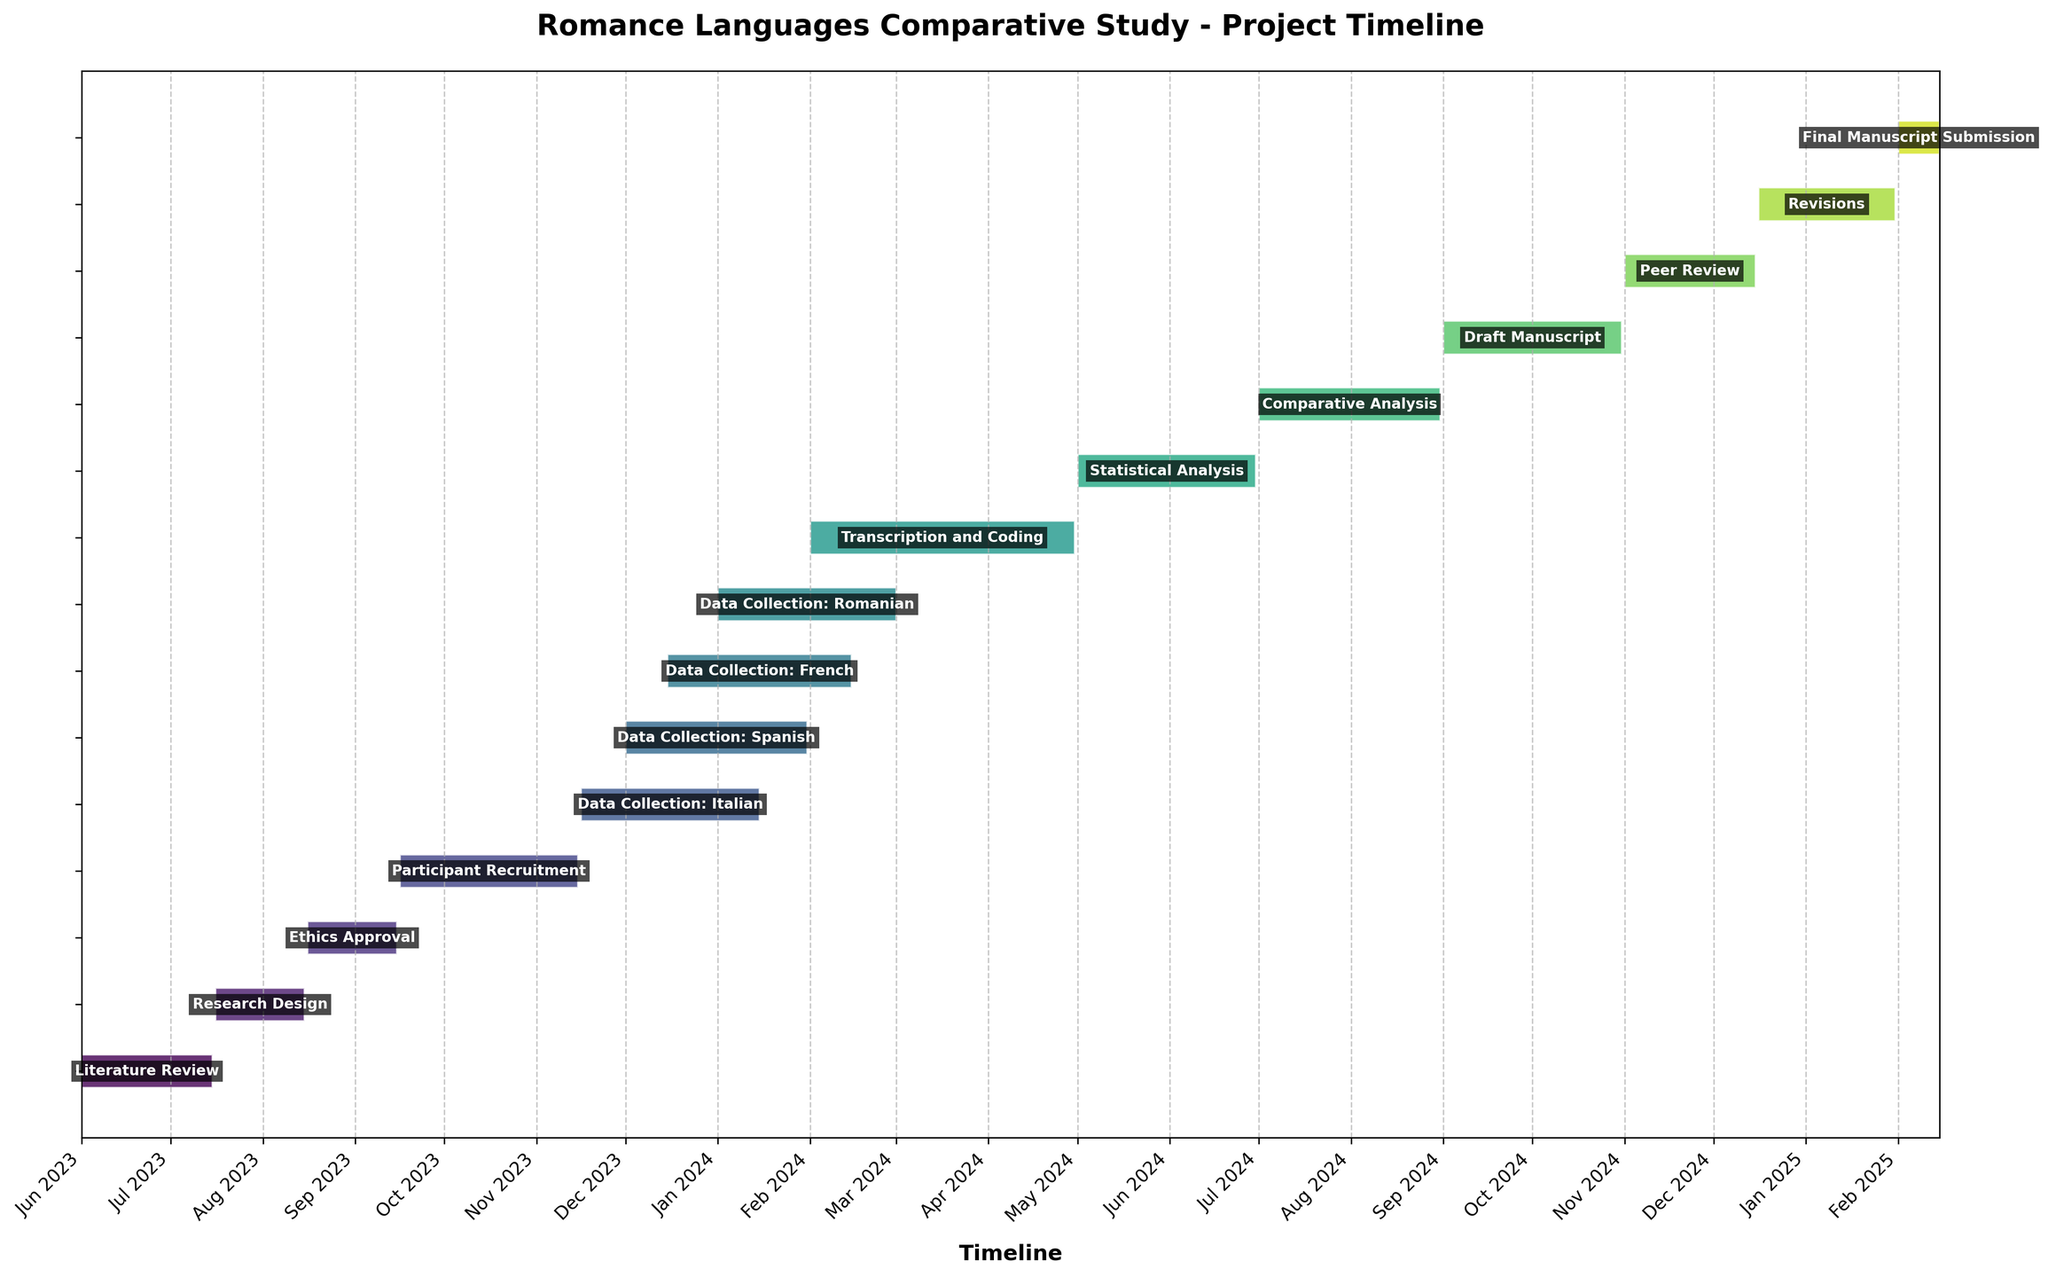What is the title of the Gantt Chart? Reading the title of the chart, "Romance Languages Comparative Study - Project Timeline" is displayed at the top.
Answer: Romance Languages Comparative Study - Project Timeline What is the duration of the 'Literature Review' phase? Locate 'Literature Review' on the chart; you can see it spans from June 1, 2023, to July 15, 2023. The duration is also indicated as 45 days.
Answer: 45 days Which task has the shortest duration? Compare the lengths of the bars. 'Final Manuscript Submission' is the shortest, spanning 15 days from February 1, 2025, to February 15, 2025.
Answer: Final Manuscript Submission How many tasks are present in the project timeline? Count the number of horizontal bars representing tasks on the chart. There are 14 tasks listed.
Answer: 14 Which language's data collection starts first? Examine the 'Data Collection' phases for each language. 'Data Collection: Italian' begins on November 16, 2023, which is the earliest.
Answer: Italian How long does the 'Transcription and Coding' phase last? Find 'Transcription and Coding' on the chart; it spans from February 1, 2024, to April 30, 2024, covering 90 days.
Answer: 90 days Which phase follows the 'Comparative Analysis'? Look at the chart sequence; 'Draft Manuscript' follows after 'Comparative Analysis' ends on August 31, 2024, starting on September 1, 2024.
Answer: Draft Manuscript How many data collection phases overlap? Identify the overlapping bars within 'Data Collection' phases: Italian (Nov 16 - Jan 15), Spanish (Dec 1 - Jan 31), French (Dec 15 - Feb 15), Romanian (Jan 1 - Mar 1). Four phases overlap between December 1, 2023, and January 15, 2024.
Answer: 4 Compare the time span of 'Ethics Approval' and 'Revisions' phases. Which one is longer? 'Ethics Approval' duration is 31 days (August 16 - September 15), whereas 'Revisions' span 47 days (December 16 - January 31). 'Revisions' is longer.
Answer: Revisions In which month does the 'Participant Recruitment' phase end? Refer to the chart, 'Participant Recruitment' ends on November 15, 2023.
Answer: November 2023 